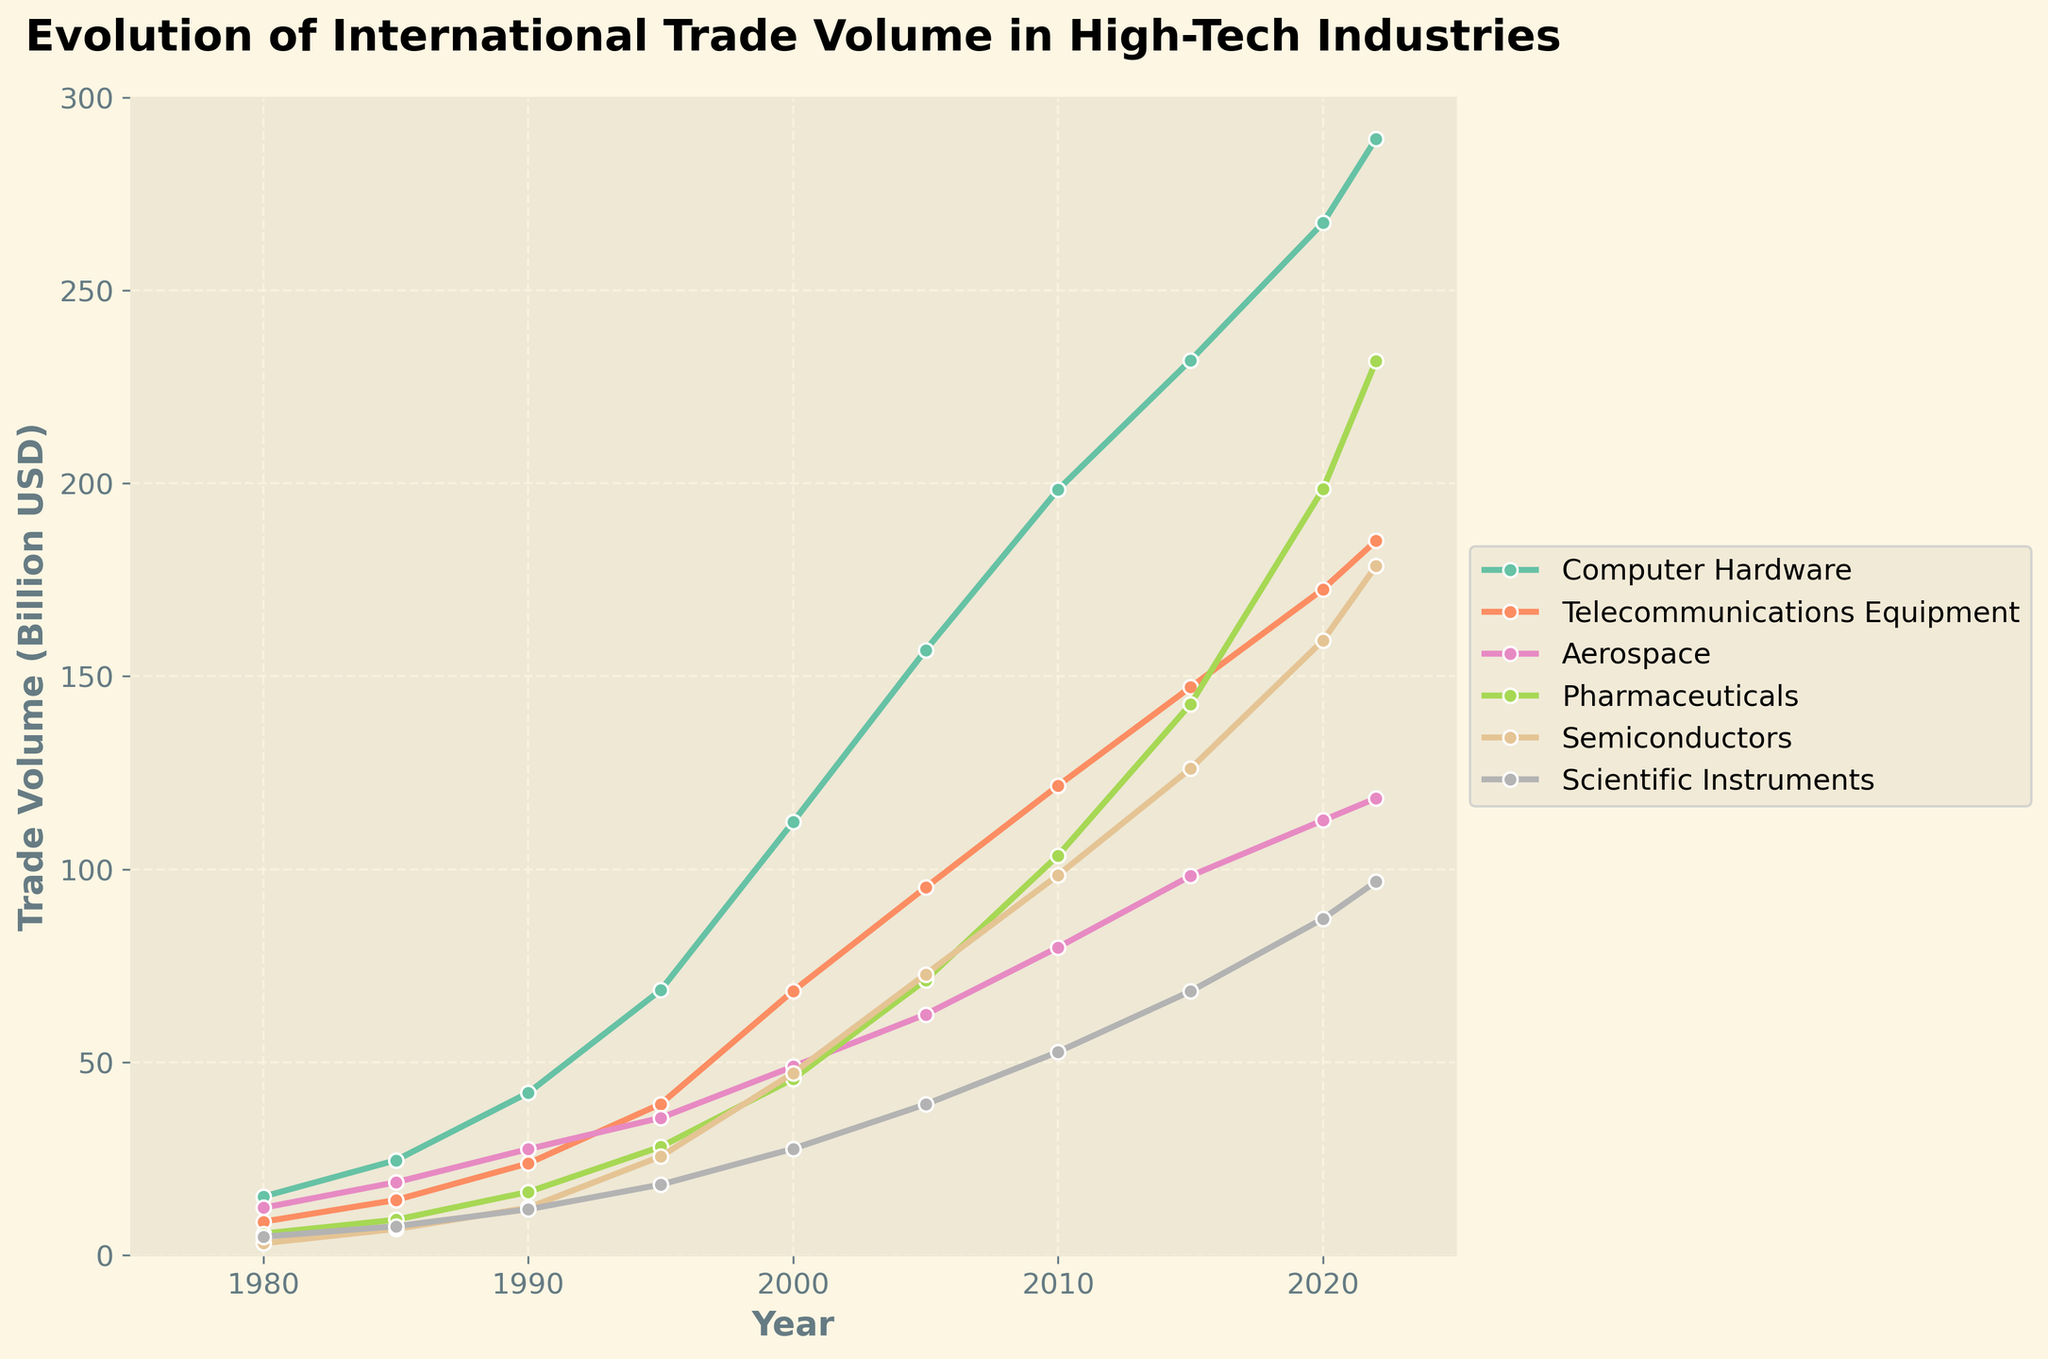What was the trade volume for Computer Hardware in 2000? Look at the data points on the chart for Computer Hardware in the year 2000. The relevant value is the y-coordinate of the point marking that year.
Answer: 112.3 billion USD Which industry had the highest trade volume in the year 2022? Compare the endpoint values (for the year 2022) of all the lines representing different industries. Identify the industry with the peak y-coordinate.
Answer: Pharmaceuticals What is the average trade volume for Telecommunications Equipment between 1980 and 2000? Add the trade volumes of Telecommunications Equipment for the years 1980, 1985, 1990, and 1995, and 2000. Then divide the sum by the number of years (5). Calculation: (8.7 + 14.3 + 23.8 + 39.2 + 68.5) / 5 = 154.5 / 5 = 30.9
Answer: 30.9 billion USD How much did the trade volume for Scientific Instruments increase from 1980 to 2022? Subtract the trade volume value for Scientific Instruments in 1980 from its value in 2022. Calculation: 96.8 - 4.8 = 92
Answer: 92 billion USD Compare the growth rate of Semiconductors to Telecommunications Equipment from 1980 to 2022. Which one grew more rapidly? Calculate the growth rate for each industry by subtracting the initial value (1980) from the final value (2022), then divide by the initial value. For Semiconductors: (178.6 - 3.1) / 3.1 ≈ 56.6. For Telecommunications Equipment: (185.1 - 8.7) / 8.7 ≈ 20.3. Compare the two figures to determine which is larger.
Answer: Semiconductors Between which consecutive years did Computer Hardware see the largest increase in trade volume? Calculate the difference in trade volume for Computer Hardware between each pair of consecutive years and identify the pair with the maximum increase.
Answer: 1990-1995 What trend do you observe in Aerospace trade volume from 1980 to 2022? Look at the shape and direction of the line representing Aerospace trade volume over the years. Understand whether it generally trends upwards, downwards, or remains stable. The line shows an upward trend, gradually increasing over the years.
Answer: Upward trend By how much did the Pharmaceuticals trade volume change between 2015 and 2020? Subtract the trade volume value for Pharmaceuticals in 2015 from its value in 2020. Calculation: 198.5 - 142.8 = 55.7
Answer: 55.7 billion USD Which industry had a lower trade volume in 2005: Semiconductors or Aerospace? Locate the points for both Semiconductors and Aerospace in the year 2005 and compare their y-coordinates.
Answer: Semiconductors What is the total combined trade volume of all high-tech industries in 1990? Sum the trade volume values for all industries in the year 1990. Calculation: 42.1 + 23.8 + 27.5 + 16.4 + 12.3 + 11.9 = 134
Answer: 134 billion USD 